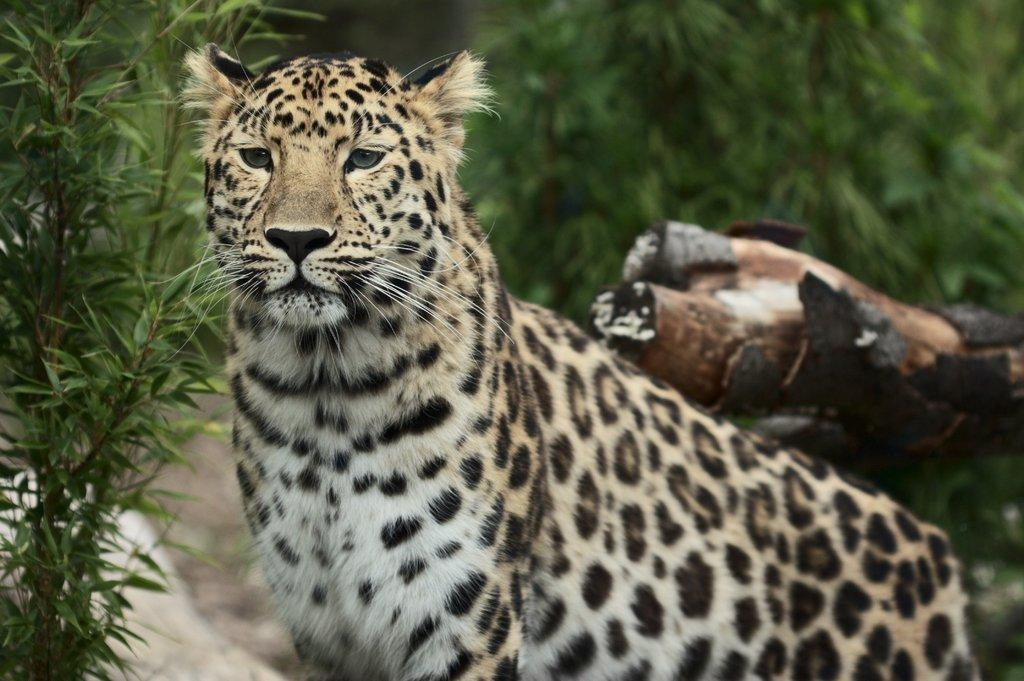What animal is in the center of the image? There is a cheetah in the center of the image. What can be seen in the background of the image? There are trees and plants in the background of the image. Can you see the ocean in the background of the image? No, the ocean is not present in the image; it features a cheetah, trees, and plants in the background. 